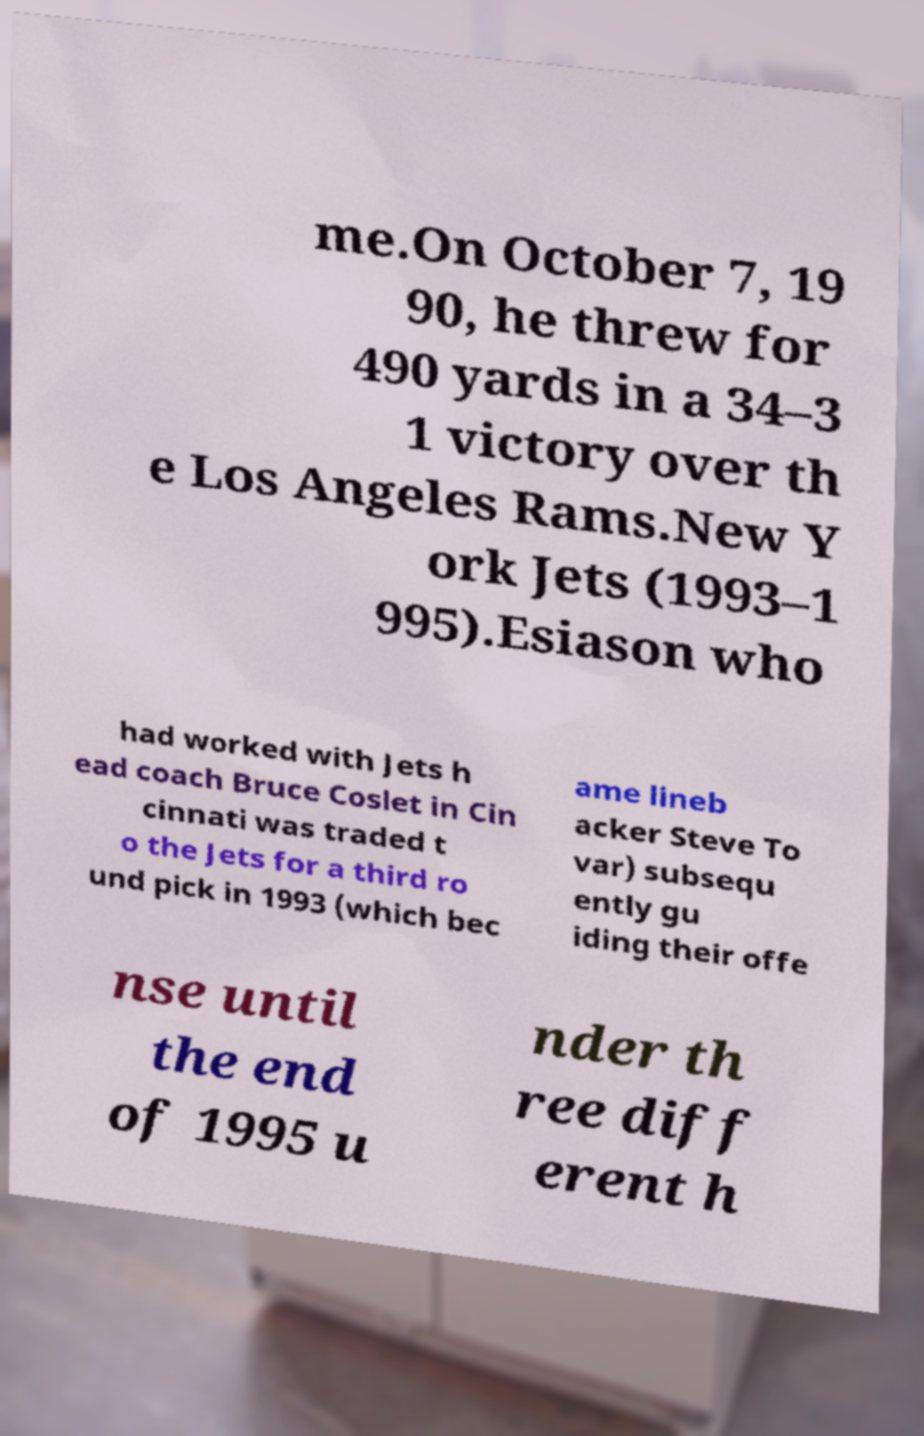Please read and relay the text visible in this image. What does it say? me.On October 7, 19 90, he threw for 490 yards in a 34–3 1 victory over th e Los Angeles Rams.New Y ork Jets (1993–1 995).Esiason who had worked with Jets h ead coach Bruce Coslet in Cin cinnati was traded t o the Jets for a third ro und pick in 1993 (which bec ame lineb acker Steve To var) subsequ ently gu iding their offe nse until the end of 1995 u nder th ree diff erent h 